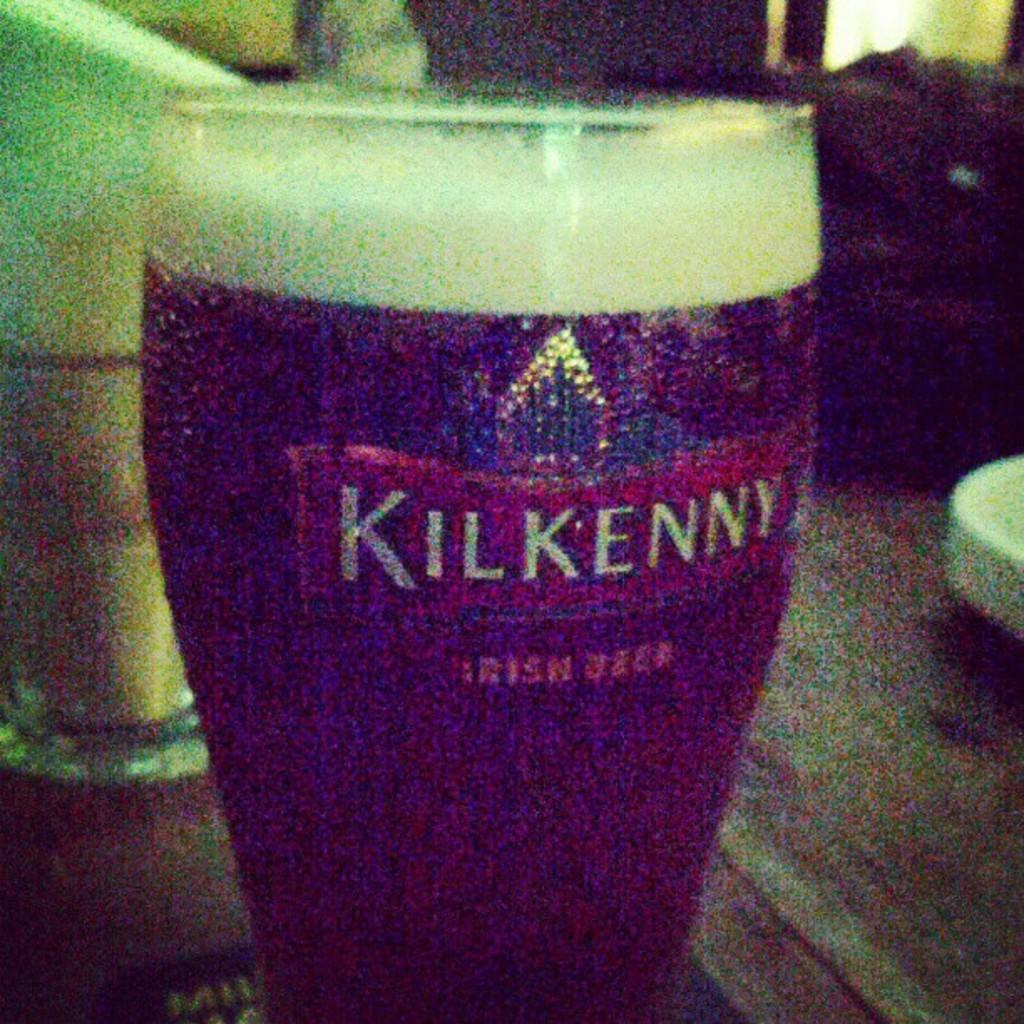<image>
Give a short and clear explanation of the subsequent image. Cup of beer and the word "Kilkenny" on it. 